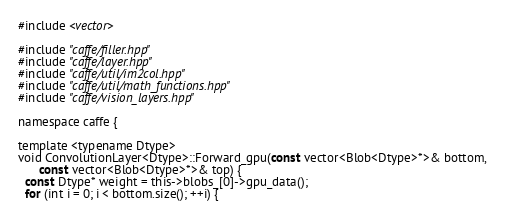Convert code to text. <code><loc_0><loc_0><loc_500><loc_500><_Cuda_>#include <vector>

#include "caffe/filler.hpp"
#include "caffe/layer.hpp"
#include "caffe/util/im2col.hpp"
#include "caffe/util/math_functions.hpp"
#include "caffe/vision_layers.hpp"

namespace caffe {

template <typename Dtype>
void ConvolutionLayer<Dtype>::Forward_gpu(const vector<Blob<Dtype>*>& bottom,
      const vector<Blob<Dtype>*>& top) {
  const Dtype* weight = this->blobs_[0]->gpu_data();
  for (int i = 0; i < bottom.size(); ++i) {</code> 